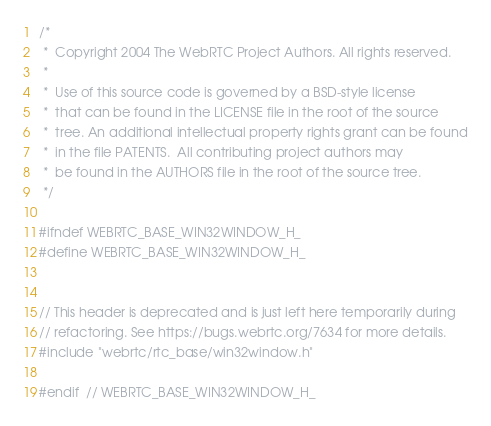Convert code to text. <code><loc_0><loc_0><loc_500><loc_500><_C_>/*
 *  Copyright 2004 The WebRTC Project Authors. All rights reserved.
 *
 *  Use of this source code is governed by a BSD-style license
 *  that can be found in the LICENSE file in the root of the source
 *  tree. An additional intellectual property rights grant can be found
 *  in the file PATENTS.  All contributing project authors may
 *  be found in the AUTHORS file in the root of the source tree.
 */

#ifndef WEBRTC_BASE_WIN32WINDOW_H_
#define WEBRTC_BASE_WIN32WINDOW_H_


// This header is deprecated and is just left here temporarily during
// refactoring. See https://bugs.webrtc.org/7634 for more details.
#include "webrtc/rtc_base/win32window.h"

#endif  // WEBRTC_BASE_WIN32WINDOW_H_
</code> 